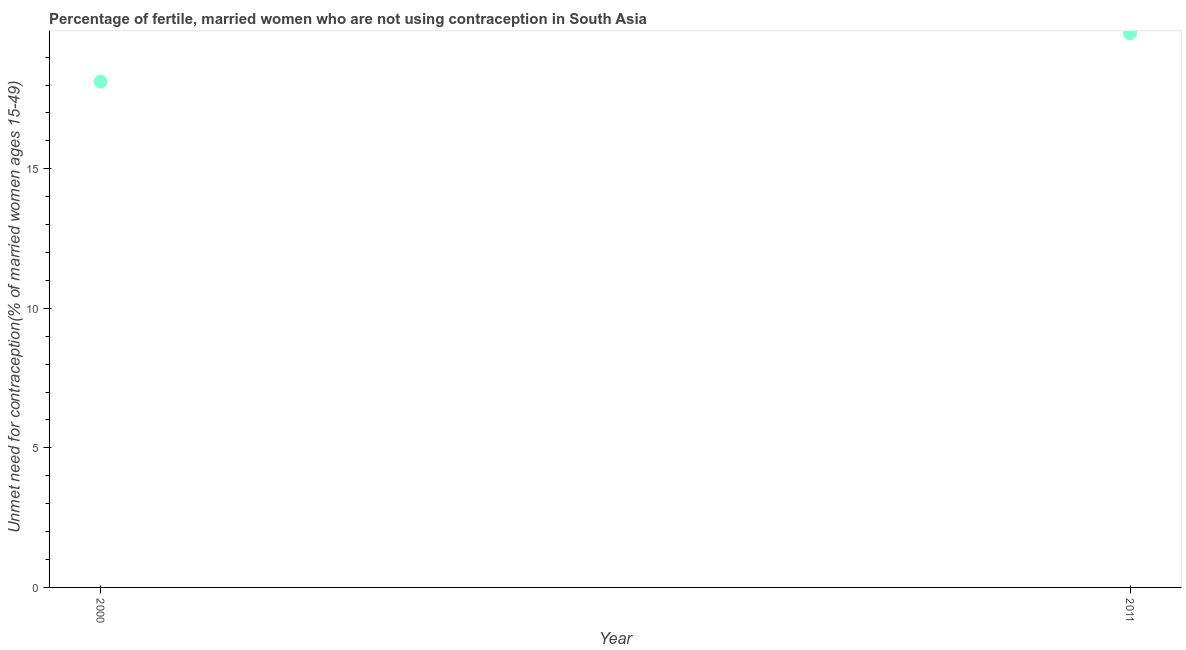What is the number of married women who are not using contraception in 2000?
Make the answer very short. 18.12. Across all years, what is the maximum number of married women who are not using contraception?
Make the answer very short. 19.86. Across all years, what is the minimum number of married women who are not using contraception?
Provide a succinct answer. 18.12. What is the sum of the number of married women who are not using contraception?
Provide a succinct answer. 37.98. What is the difference between the number of married women who are not using contraception in 2000 and 2011?
Your answer should be compact. -1.73. What is the average number of married women who are not using contraception per year?
Your response must be concise. 18.99. What is the median number of married women who are not using contraception?
Keep it short and to the point. 18.99. In how many years, is the number of married women who are not using contraception greater than 8 %?
Your answer should be compact. 2. What is the ratio of the number of married women who are not using contraception in 2000 to that in 2011?
Make the answer very short. 0.91. How many years are there in the graph?
Provide a short and direct response. 2. What is the difference between two consecutive major ticks on the Y-axis?
Make the answer very short. 5. Does the graph contain any zero values?
Make the answer very short. No. What is the title of the graph?
Offer a very short reply. Percentage of fertile, married women who are not using contraception in South Asia. What is the label or title of the Y-axis?
Ensure brevity in your answer.   Unmet need for contraception(% of married women ages 15-49). What is the  Unmet need for contraception(% of married women ages 15-49) in 2000?
Offer a terse response. 18.12. What is the  Unmet need for contraception(% of married women ages 15-49) in 2011?
Keep it short and to the point. 19.86. What is the difference between the  Unmet need for contraception(% of married women ages 15-49) in 2000 and 2011?
Give a very brief answer. -1.73. What is the ratio of the  Unmet need for contraception(% of married women ages 15-49) in 2000 to that in 2011?
Offer a terse response. 0.91. 